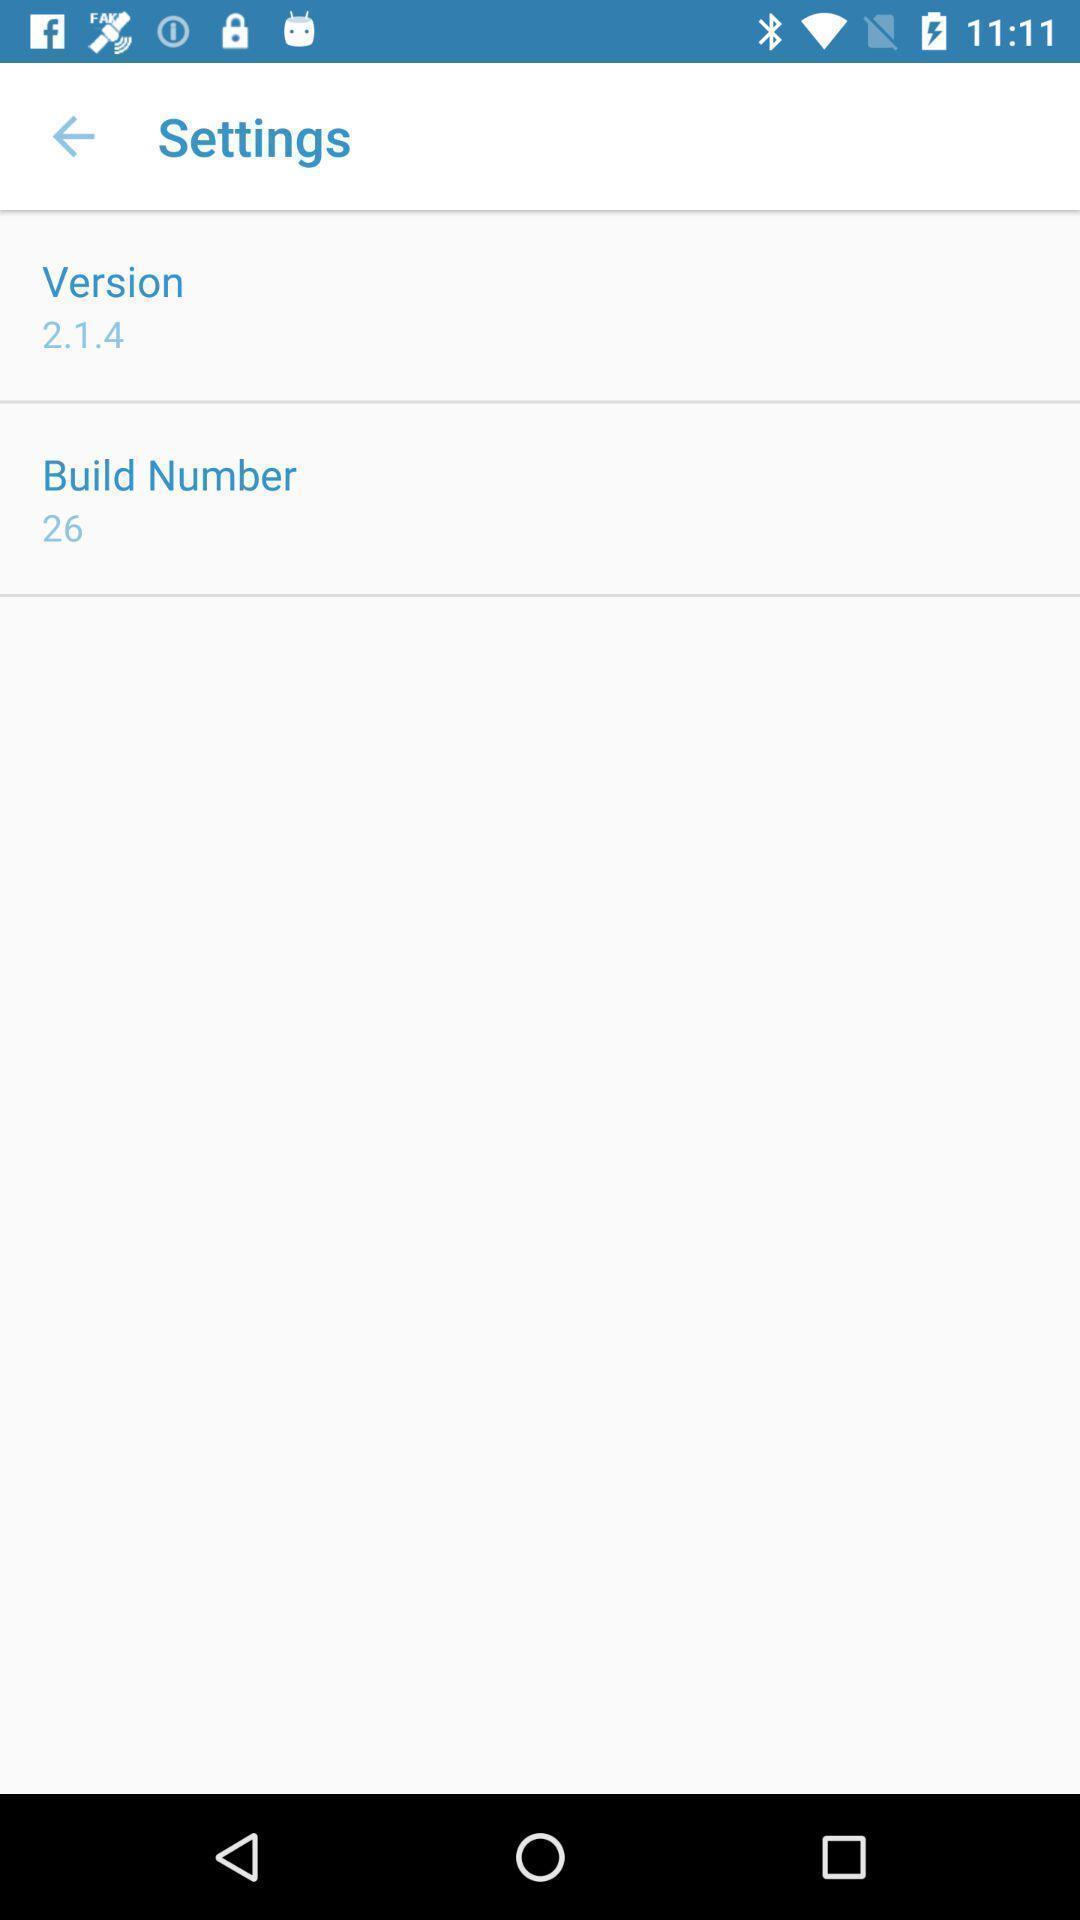Describe this image in words. Settings page displaying the version of the app. 